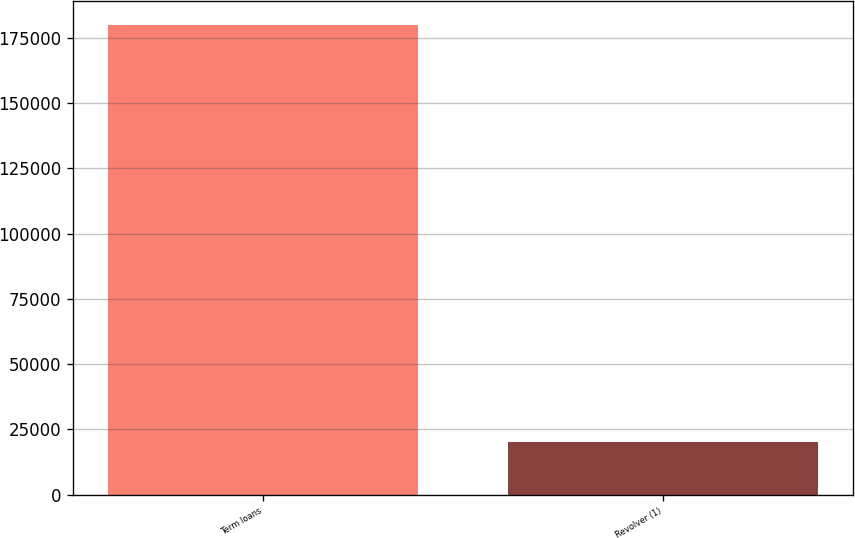Convert chart to OTSL. <chart><loc_0><loc_0><loc_500><loc_500><bar_chart><fcel>Term loans<fcel>Revolver (1)<nl><fcel>180000<fcel>20000<nl></chart> 